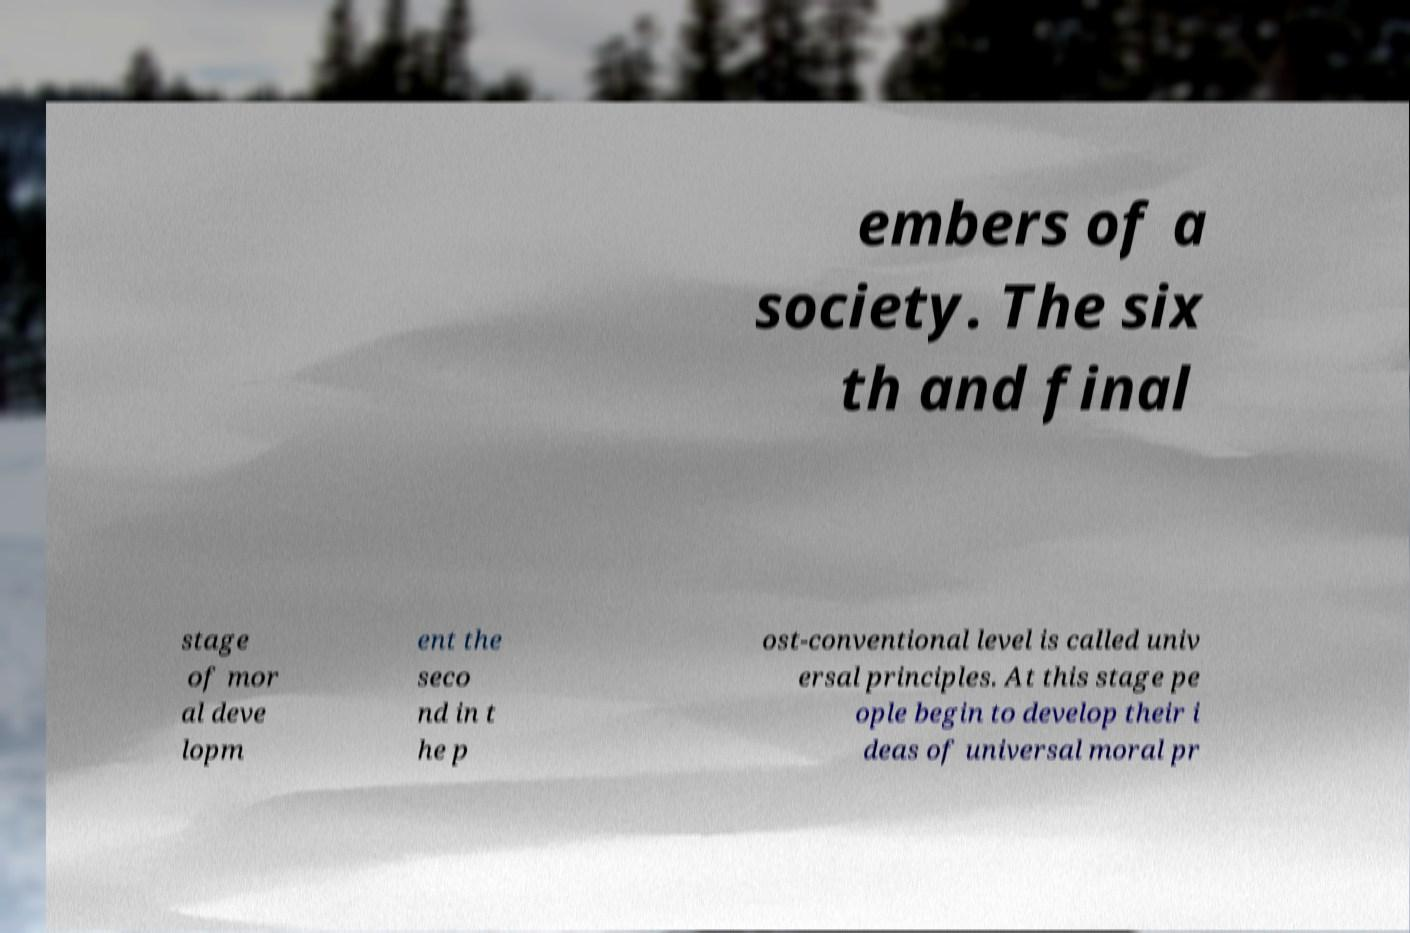Could you extract and type out the text from this image? embers of a society. The six th and final stage of mor al deve lopm ent the seco nd in t he p ost-conventional level is called univ ersal principles. At this stage pe ople begin to develop their i deas of universal moral pr 